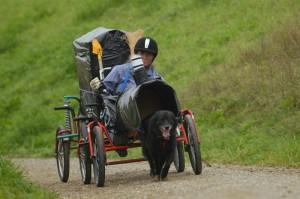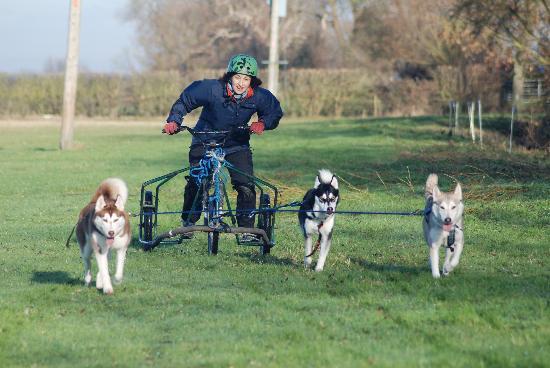The first image is the image on the left, the second image is the image on the right. For the images shown, is this caption "There are two dogs." true? Answer yes or no. No. The first image is the image on the left, the second image is the image on the right. Assess this claim about the two images: "An image shows a person in a helmet riding a four-wheeled cart pulled by one dog diagonally to the right.". Correct or not? Answer yes or no. Yes. 